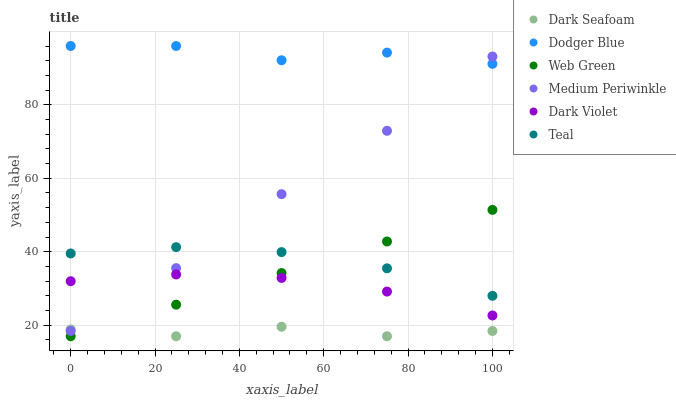Does Dark Seafoam have the minimum area under the curve?
Answer yes or no. Yes. Does Dodger Blue have the maximum area under the curve?
Answer yes or no. Yes. Does Dark Violet have the minimum area under the curve?
Answer yes or no. No. Does Dark Violet have the maximum area under the curve?
Answer yes or no. No. Is Web Green the smoothest?
Answer yes or no. Yes. Is Dodger Blue the roughest?
Answer yes or no. Yes. Is Dark Violet the smoothest?
Answer yes or no. No. Is Dark Violet the roughest?
Answer yes or no. No. Does Dark Seafoam have the lowest value?
Answer yes or no. Yes. Does Dark Violet have the lowest value?
Answer yes or no. No. Does Dodger Blue have the highest value?
Answer yes or no. Yes. Does Dark Violet have the highest value?
Answer yes or no. No. Is Dark Violet less than Dodger Blue?
Answer yes or no. Yes. Is Dodger Blue greater than Dark Seafoam?
Answer yes or no. Yes. Does Teal intersect Web Green?
Answer yes or no. Yes. Is Teal less than Web Green?
Answer yes or no. No. Is Teal greater than Web Green?
Answer yes or no. No. Does Dark Violet intersect Dodger Blue?
Answer yes or no. No. 